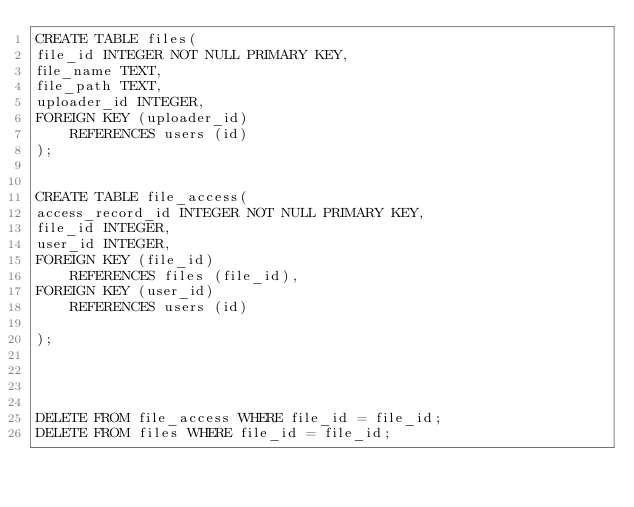<code> <loc_0><loc_0><loc_500><loc_500><_SQL_>CREATE TABLE files(
file_id INTEGER NOT NULL PRIMARY KEY,
file_name TEXT,
file_path TEXT,
uploader_id INTEGER,
FOREIGN KEY (uploader_id)
    REFERENCES users (id)
);


CREATE TABLE file_access(
access_record_id INTEGER NOT NULL PRIMARY KEY,
file_id INTEGER,
user_id INTEGER,
FOREIGN KEY (file_id)
    REFERENCES files (file_id),
FOREIGN KEY (user_id)
    REFERENCES users (id)

);




DELETE FROM file_access WHERE file_id = file_id; 
DELETE FROM files WHERE file_id = file_id; </code> 